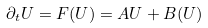Convert formula to latex. <formula><loc_0><loc_0><loc_500><loc_500>\partial _ { t } U = F ( U ) = A U + B ( U )</formula> 